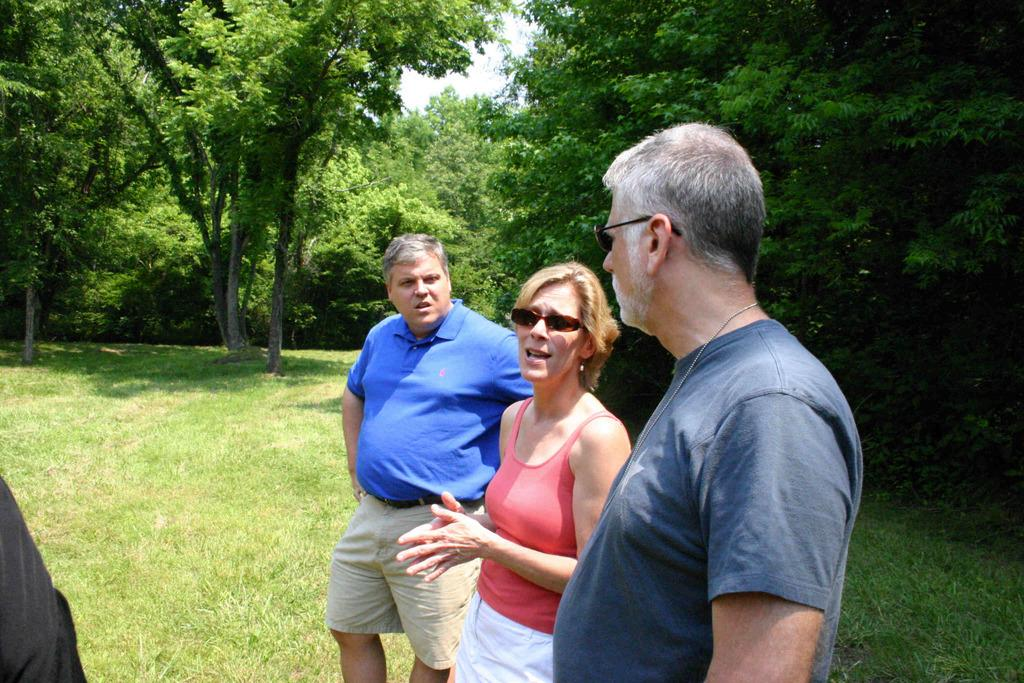Who is the main subject in the image? There is a woman in the image. What is the woman wearing? The woman is wearing a pink vest. How is the woman positioned in relation to the men in the image? The woman is standing in the middle of two men. What is the setting of the image? The scene takes place on grass land. What can be seen in the background of the image? There are trees in the background of the image. What type of ray is visible in the image? There is no ray present in the image. What is the woman using to rake the grass in the image? The woman is not using a rake in the image; she is simply standing between two men. 